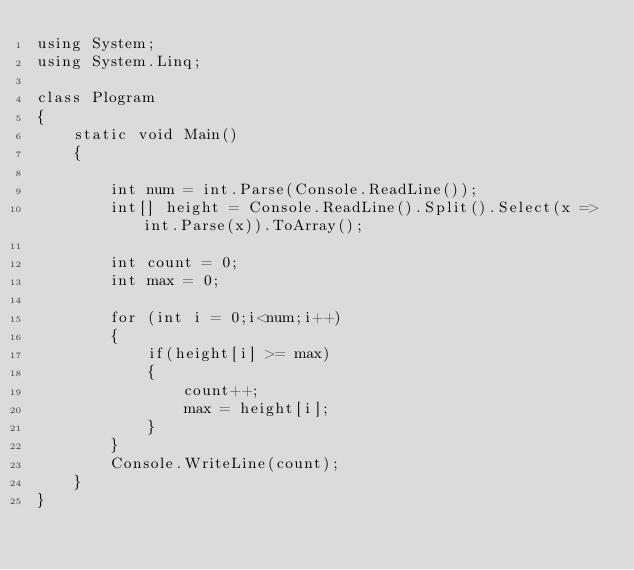<code> <loc_0><loc_0><loc_500><loc_500><_C#_>using System;
using System.Linq;

class Plogram
{
    static void Main()
    {

        int num = int.Parse(Console.ReadLine());
        int[] height = Console.ReadLine().Split().Select(x => int.Parse(x)).ToArray();

        int count = 0;
        int max = 0;

        for (int i = 0;i<num;i++)
        {
            if(height[i] >= max)
            {
                count++;
                max = height[i];
            }
        }
        Console.WriteLine(count);
    }
}</code> 